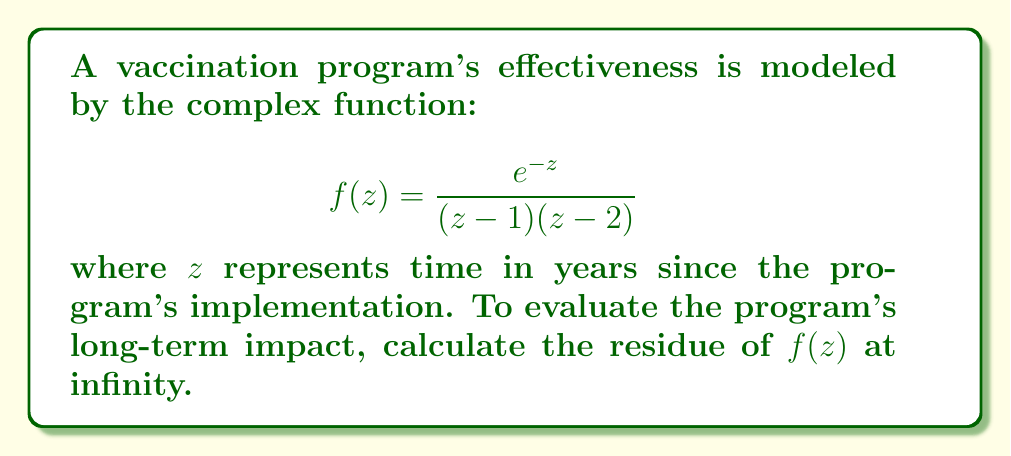Solve this math problem. To find the residue at infinity, we follow these steps:

1) First, we need to transform the function to evaluate the residue at $z=0$ instead of infinity. We do this by substituting $w = \frac{1}{z}$:

   $$f(w) = \frac{e^{-1/w}}{(1/w-1)(1/w-2)} \cdot (-\frac{1}{w^2})$$

2) Simplify:
   
   $$f(w) = -\frac{w^2e^{-1/w}}{(1-w)(1-2w)}$$

3) The residue at infinity of $f(z)$ is the negative of the coefficient of $w$ in the Laurent series expansion of $f(w)$ about $w=0$.

4) Expand $e^{-1/w}$ in a Taylor series:

   $$e^{-1/w} = 1 - \frac{1}{w} + \frac{1}{2!w^2} - \frac{1}{3!w^3} + ...$$

5) Multiply by $w^2$ and expand $(1-w)(1-2w)$ in the denominator:

   $$f(w) = -\frac{w^2 - w + \frac{1}{2!} - \frac{1}{3!w} + ...}{1 - 3w + 2w^2}$$

6) Divide the numerator by the denominator using long division, we get:

   $$f(w) = -w + 3 + O(w)$$

7) The coefficient of $w$ in this expansion is -1.

Therefore, the residue at infinity is the negative of this coefficient, which is 1.
Answer: The residue of $f(z)$ at infinity is 1. 